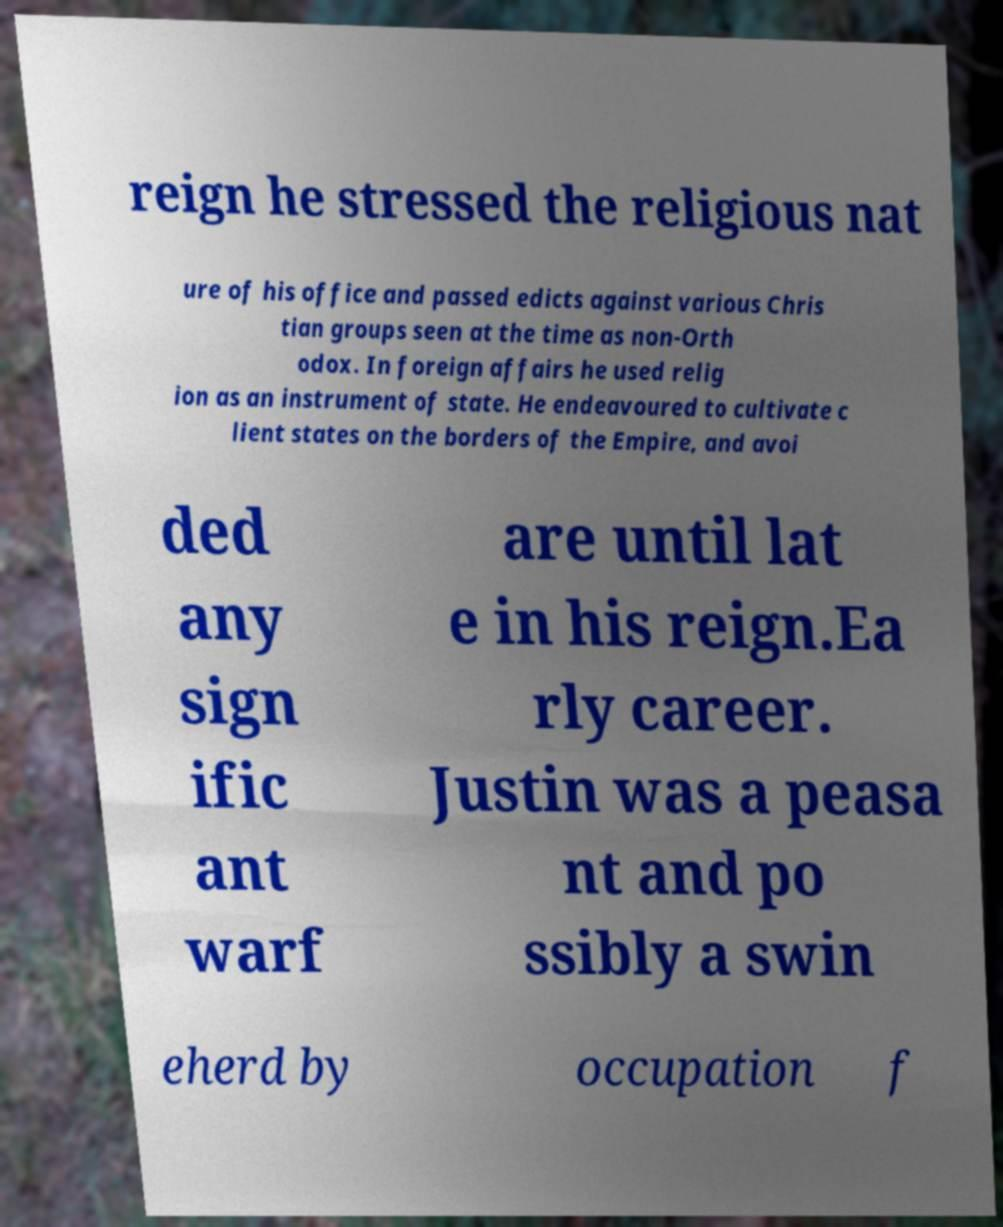I need the written content from this picture converted into text. Can you do that? reign he stressed the religious nat ure of his office and passed edicts against various Chris tian groups seen at the time as non-Orth odox. In foreign affairs he used relig ion as an instrument of state. He endeavoured to cultivate c lient states on the borders of the Empire, and avoi ded any sign ific ant warf are until lat e in his reign.Ea rly career. Justin was a peasa nt and po ssibly a swin eherd by occupation f 